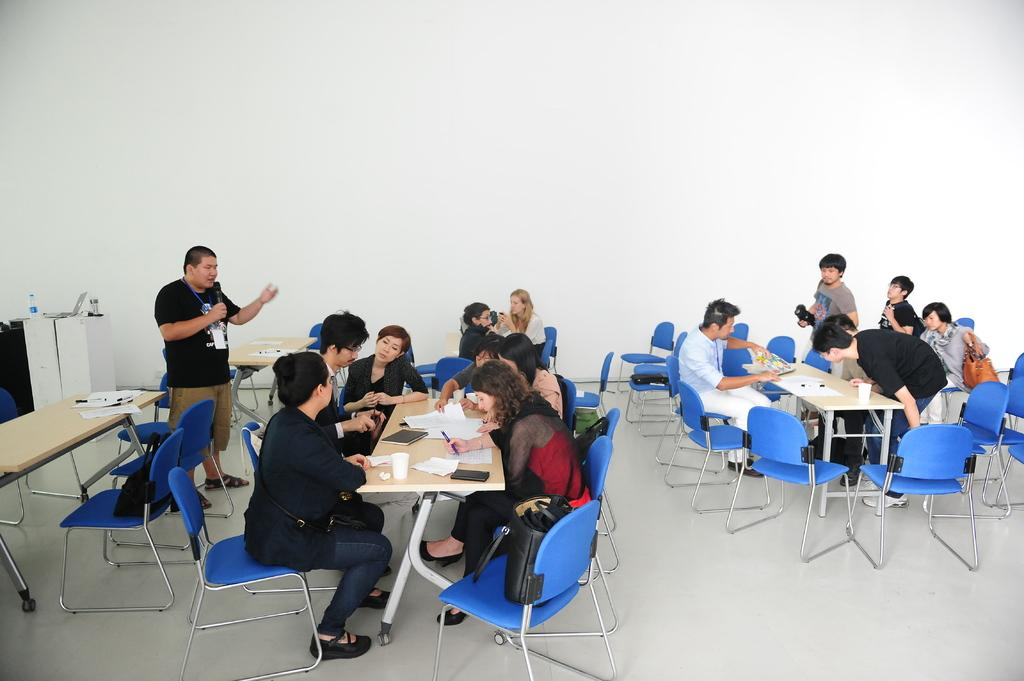What is the main activity of the group of people in the image? The group of people in the image are eating food and talking to each other. What is the setting of the image? The group of people are sitting around a table. Are there any other objects or items visible in the image? No specific objects or items are mentioned in the provided facts. How many houses can be seen in the image? There is no mention of houses in the provided facts, so we cannot determine the number of houses in the image. 